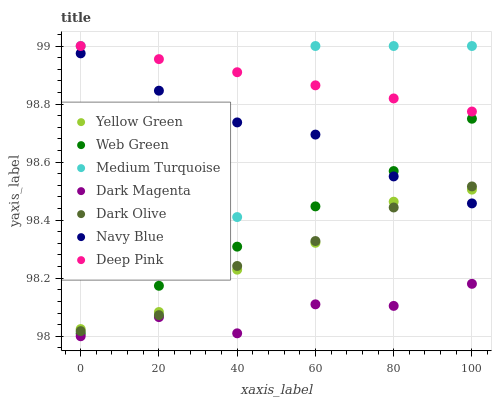Does Dark Magenta have the minimum area under the curve?
Answer yes or no. Yes. Does Deep Pink have the maximum area under the curve?
Answer yes or no. Yes. Does Yellow Green have the minimum area under the curve?
Answer yes or no. No. Does Yellow Green have the maximum area under the curve?
Answer yes or no. No. Is Deep Pink the smoothest?
Answer yes or no. Yes. Is Medium Turquoise the roughest?
Answer yes or no. Yes. Is Yellow Green the smoothest?
Answer yes or no. No. Is Yellow Green the roughest?
Answer yes or no. No. Does Dark Magenta have the lowest value?
Answer yes or no. Yes. Does Yellow Green have the lowest value?
Answer yes or no. No. Does Medium Turquoise have the highest value?
Answer yes or no. Yes. Does Yellow Green have the highest value?
Answer yes or no. No. Is Dark Magenta less than Deep Pink?
Answer yes or no. Yes. Is Deep Pink greater than Yellow Green?
Answer yes or no. Yes. Does Medium Turquoise intersect Dark Olive?
Answer yes or no. Yes. Is Medium Turquoise less than Dark Olive?
Answer yes or no. No. Is Medium Turquoise greater than Dark Olive?
Answer yes or no. No. Does Dark Magenta intersect Deep Pink?
Answer yes or no. No. 